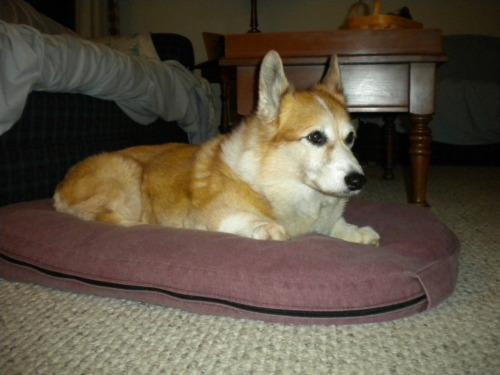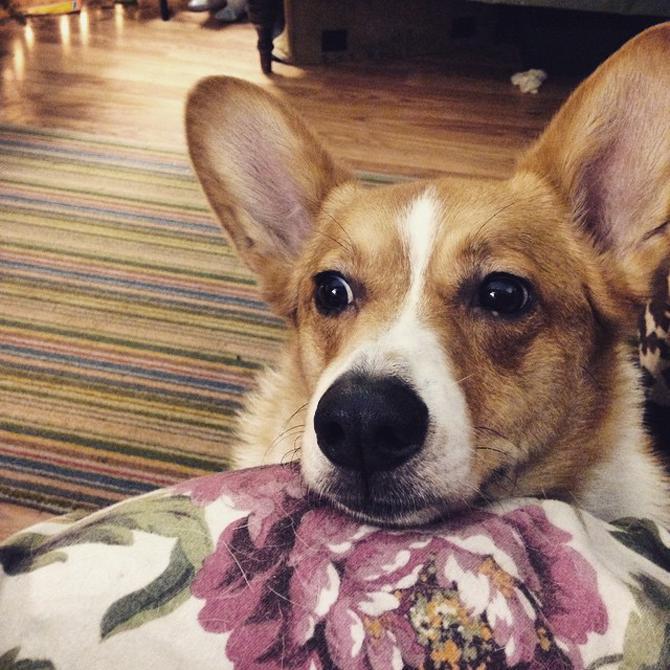The first image is the image on the left, the second image is the image on the right. For the images shown, is this caption "All corgis are reclining on wood floors, and at least one corgi has its eyes shut." true? Answer yes or no. No. The first image is the image on the left, the second image is the image on the right. Analyze the images presented: Is the assertion "The left image contains a dog that is laying down inside on a wooden floor." valid? Answer yes or no. No. 